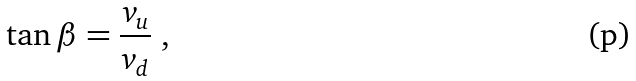Convert formula to latex. <formula><loc_0><loc_0><loc_500><loc_500>\tan \beta = \frac { v _ { u } } { v _ { d } } \ ,</formula> 